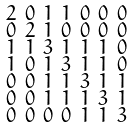<formula> <loc_0><loc_0><loc_500><loc_500>\begin{smallmatrix} 2 & 0 & 1 & 1 & 0 & 0 & 0 \\ 0 & 2 & 1 & 0 & 0 & 0 & 0 \\ 1 & 1 & 3 & 1 & 1 & 1 & 0 \\ 1 & 0 & 1 & 3 & 1 & 1 & 0 \\ 0 & 0 & 1 & 1 & 3 & 1 & 1 \\ 0 & 0 & 1 & 1 & 1 & 3 & 1 \\ 0 & 0 & 0 & 0 & 1 & 1 & 3 \end{smallmatrix}</formula> 